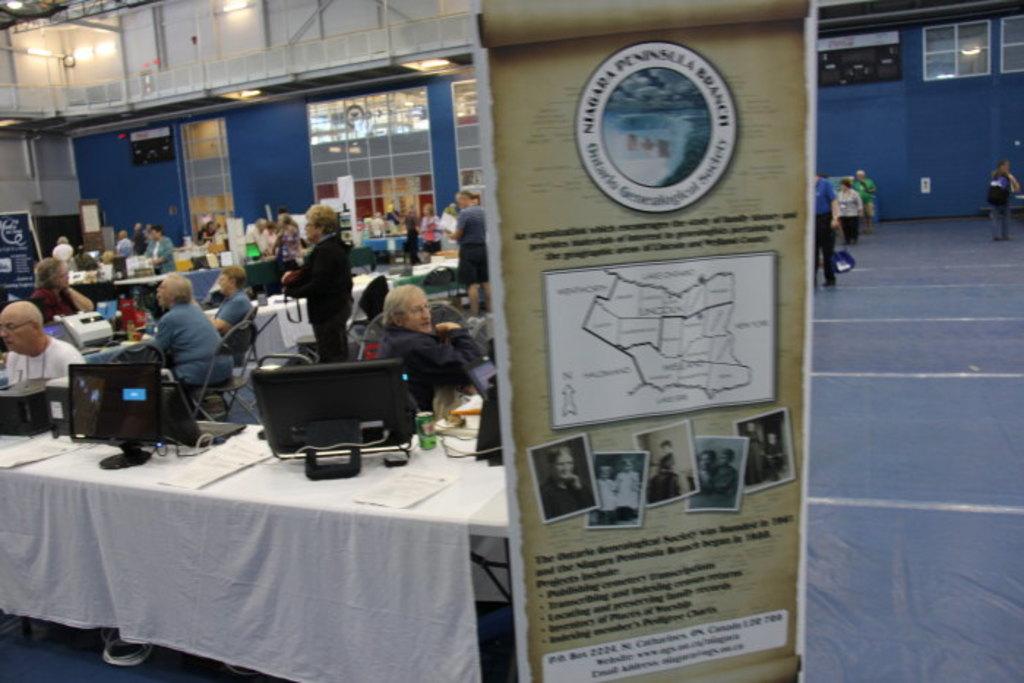What is the logo on the sign?
Offer a terse response. Niagara peninsula branch. 